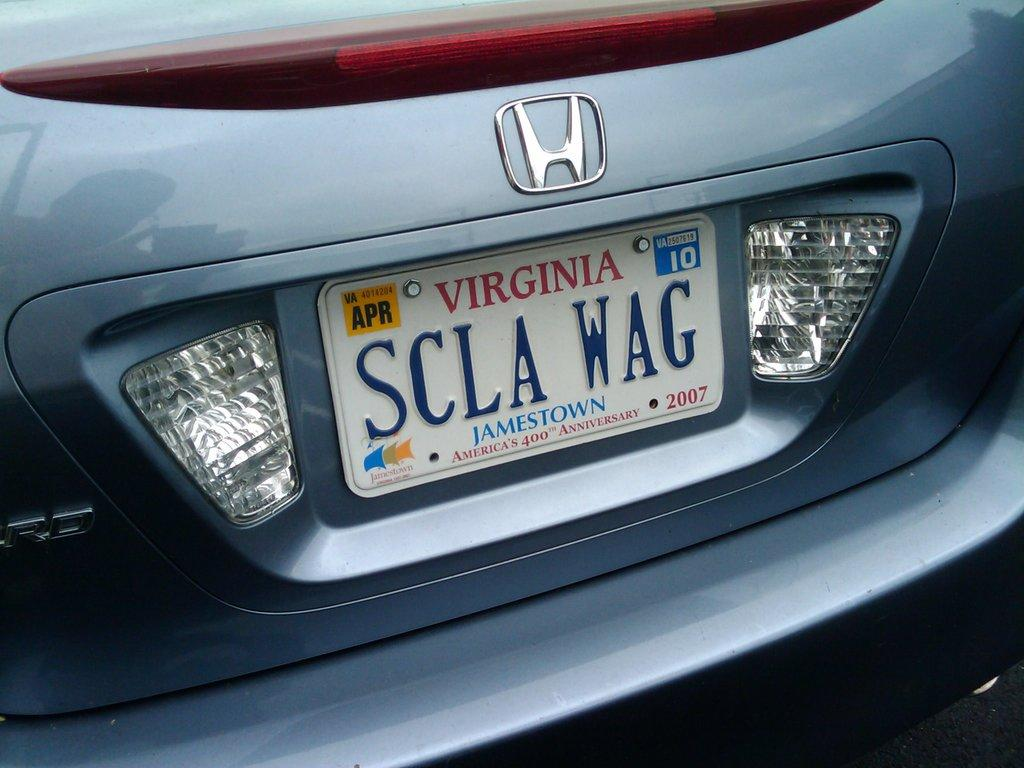Provide a one-sentence caption for the provided image. A personalized license plate makes a play on words displaying "SCLA WAG". 